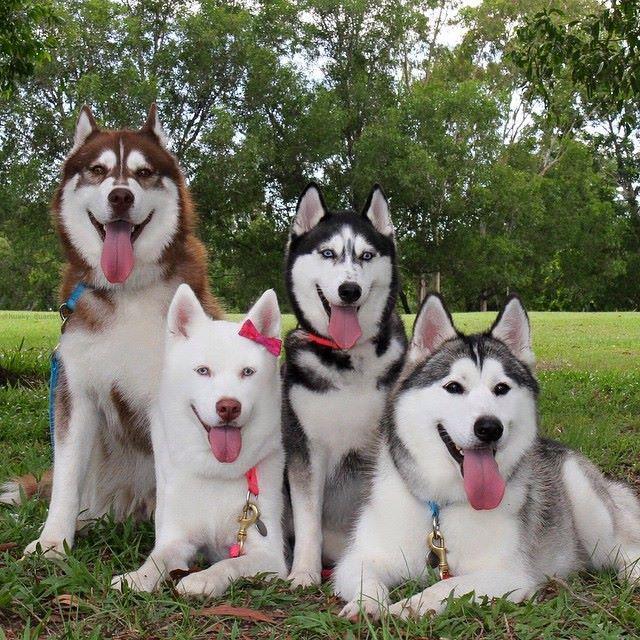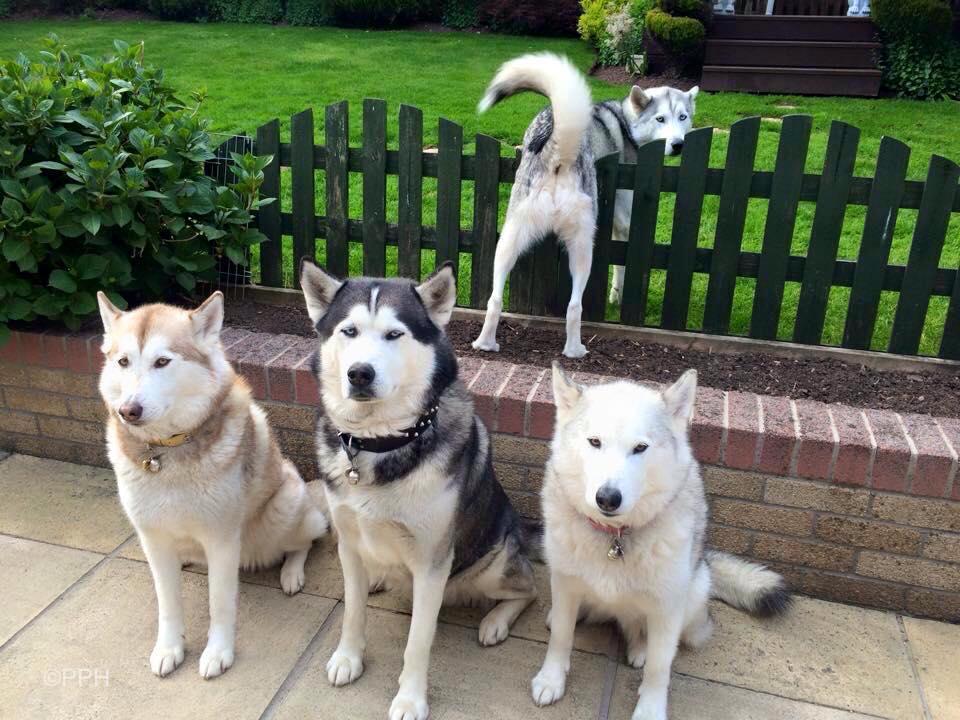The first image is the image on the left, the second image is the image on the right. Evaluate the accuracy of this statement regarding the images: "There are exactly eight dogs.". Is it true? Answer yes or no. Yes. 